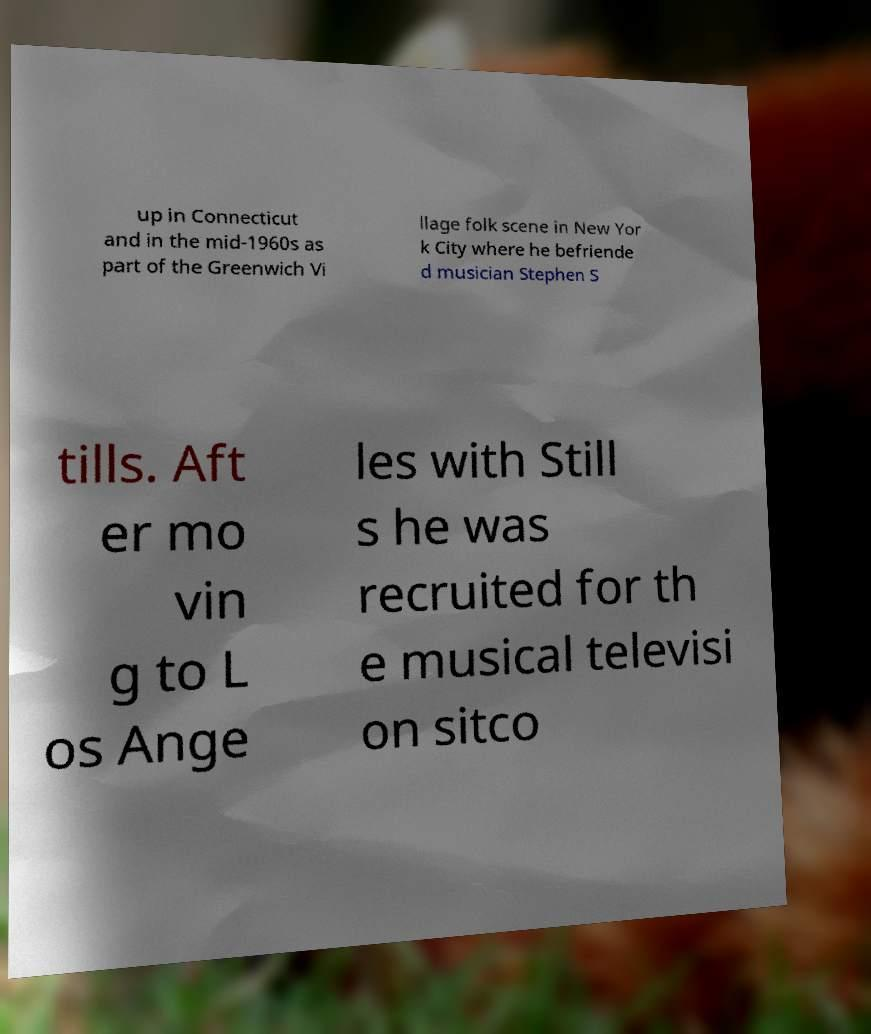There's text embedded in this image that I need extracted. Can you transcribe it verbatim? up in Connecticut and in the mid-1960s as part of the Greenwich Vi llage folk scene in New Yor k City where he befriende d musician Stephen S tills. Aft er mo vin g to L os Ange les with Still s he was recruited for th e musical televisi on sitco 